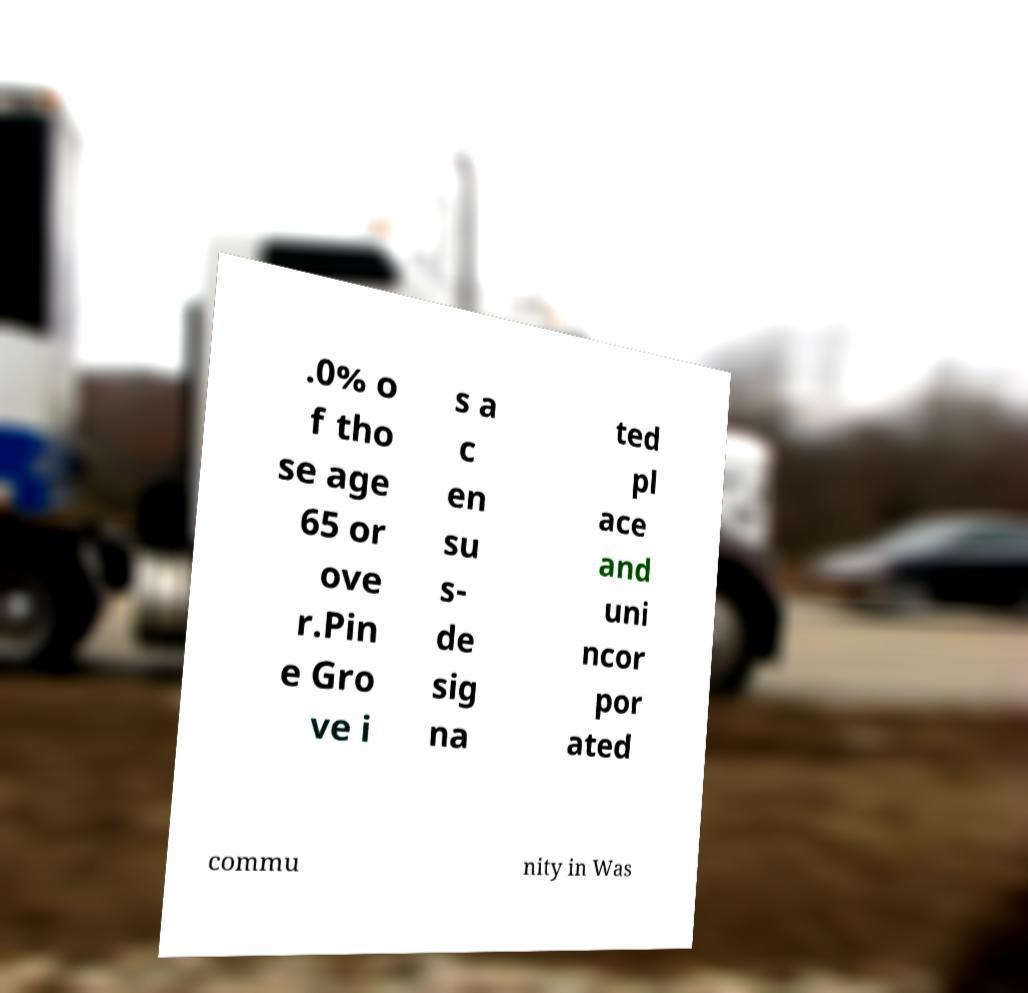Can you read and provide the text displayed in the image?This photo seems to have some interesting text. Can you extract and type it out for me? .0% o f tho se age 65 or ove r.Pin e Gro ve i s a c en su s- de sig na ted pl ace and uni ncor por ated commu nity in Was 